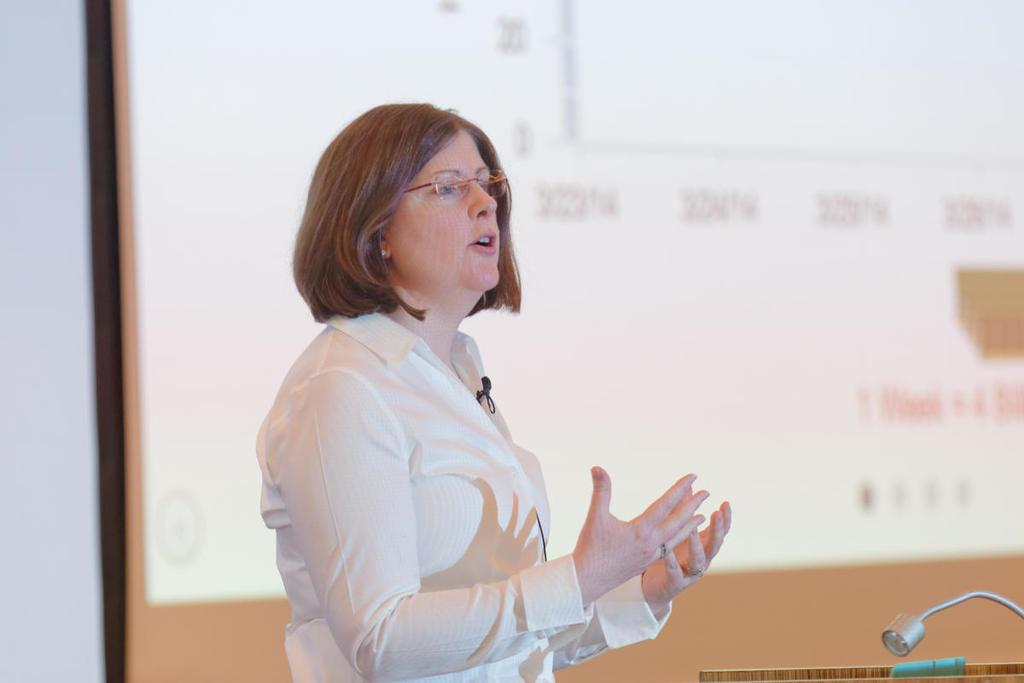Who is the main subject in the image? There is a woman in the image. What is the woman wearing? The woman is wearing a white shirt. What is the woman holding in the image? The woman is wearing a mic. Where is the woman located in the image? The woman is speaking on a stage. What is present in front of the stage? There is a stand with a mic in front of the stage. What can be seen in the background of the image? There is a screen in the background and a white wall near the screen. How many frogs are sitting on the home in the image? There is no home or frogs present in the image. What things can be seen on the stage with the woman? The provided facts do not mention any specific things on the stage with the woman, only the mic stand and screen in the background. 